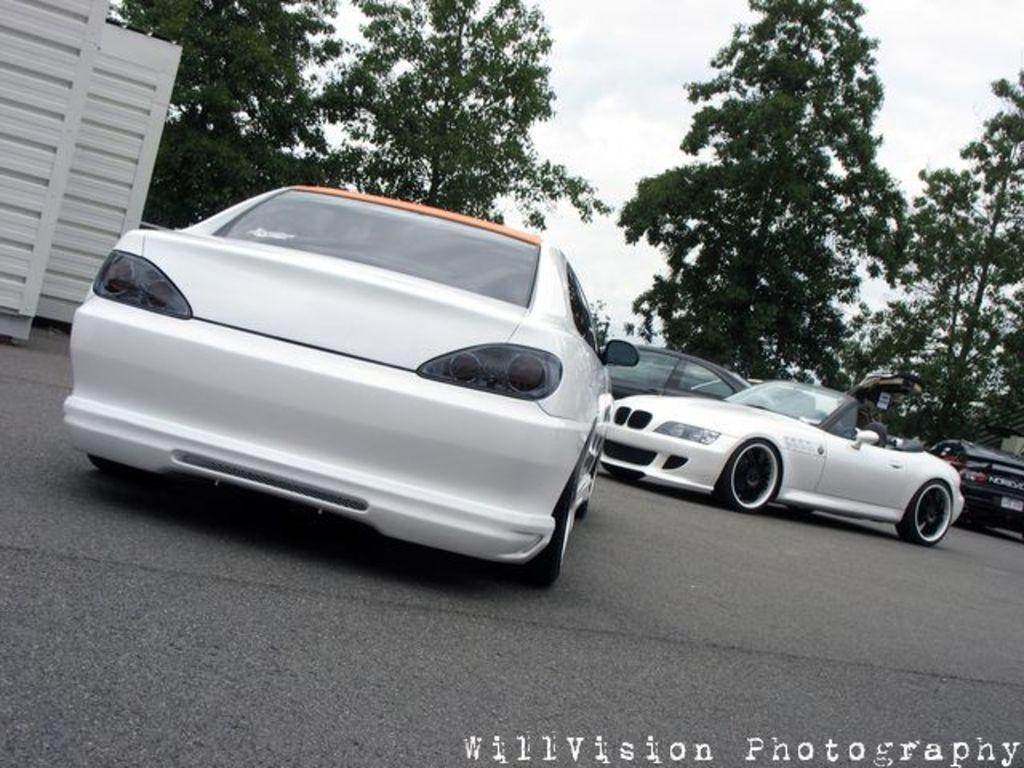What is happening on the road in the image? There are cars on the road in the image. What else can be seen beside the road? There is a part of a wall visible beside the road. What type of vegetation is in the background of the image? There are trees in the background of the image. What is visible in the sky in the image? The sky is visible in the background of the image, and clouds are present. What color is the chalk used to draw on the scene in the image? There is no chalk or drawing present in the image; it features cars on the road, a wall, trees, and clouds in the sky. 